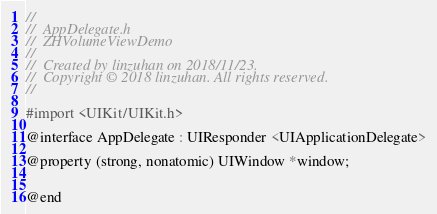Convert code to text. <code><loc_0><loc_0><loc_500><loc_500><_C_>//
//  AppDelegate.h
//  ZHVolumeViewDemo
//
//  Created by linzuhan on 2018/11/23.
//  Copyright © 2018 linzuhan. All rights reserved.
//

#import <UIKit/UIKit.h>

@interface AppDelegate : UIResponder <UIApplicationDelegate>

@property (strong, nonatomic) UIWindow *window;


@end

</code> 